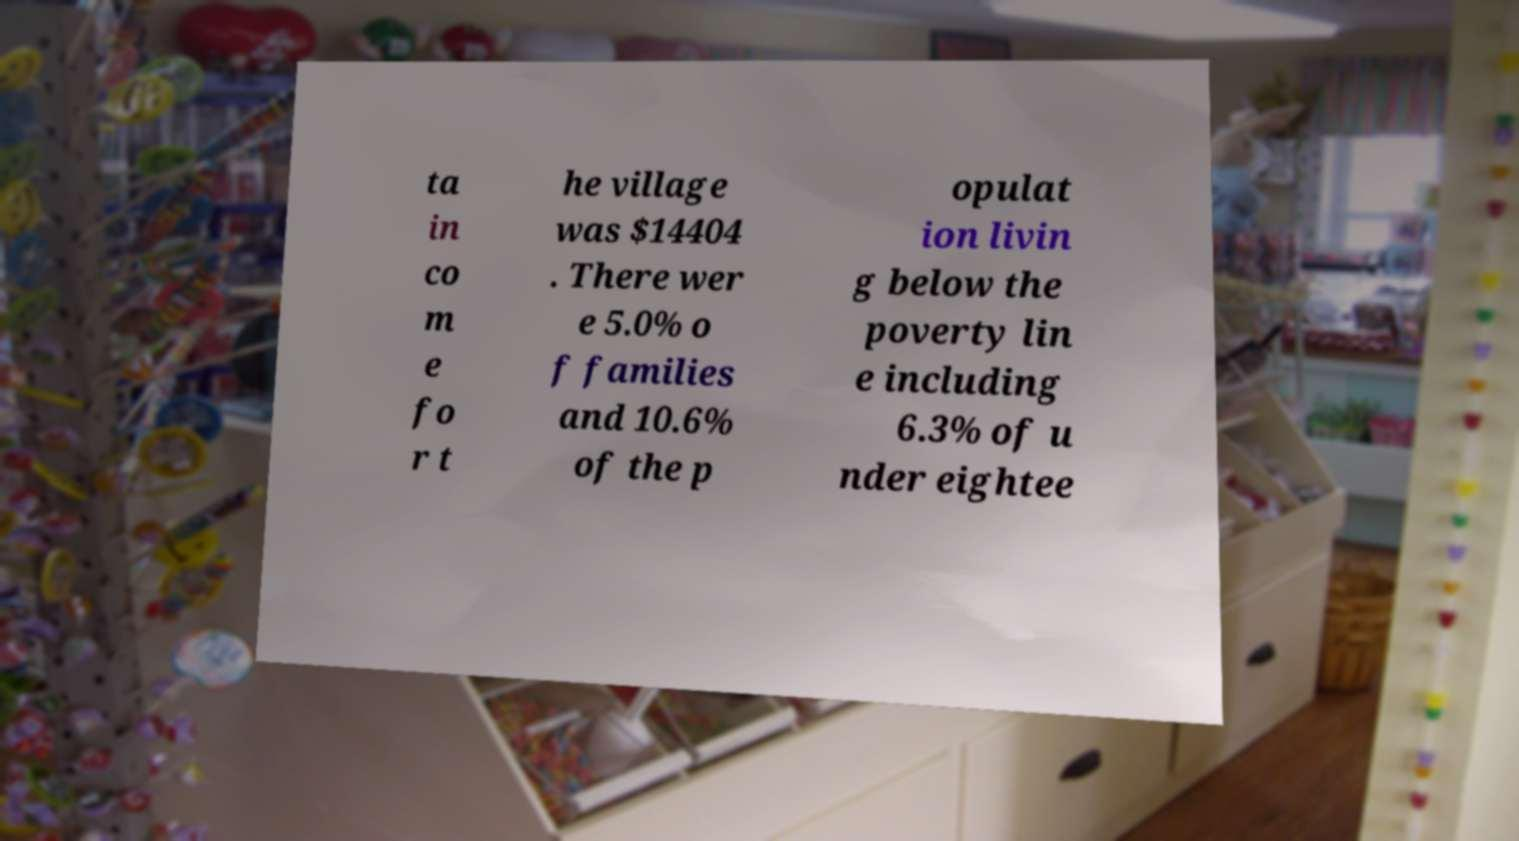I need the written content from this picture converted into text. Can you do that? ta in co m e fo r t he village was $14404 . There wer e 5.0% o f families and 10.6% of the p opulat ion livin g below the poverty lin e including 6.3% of u nder eightee 